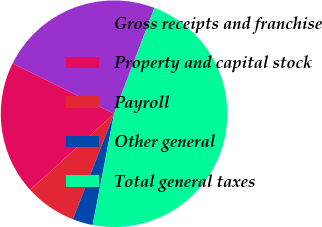Convert chart. <chart><loc_0><loc_0><loc_500><loc_500><pie_chart><fcel>Gross receipts and franchise<fcel>Property and capital stock<fcel>Payroll<fcel>Other general<fcel>Total general taxes<nl><fcel>23.47%<fcel>19.04%<fcel>7.35%<fcel>2.91%<fcel>47.22%<nl></chart> 